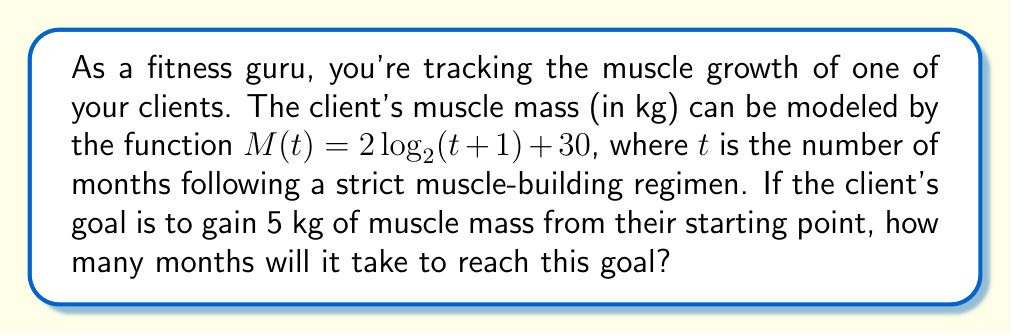Give your solution to this math problem. Let's approach this step-by-step:

1) The initial muscle mass (at $t=0$) is:
   $M(0) = 2\log_2(0+1) + 30 = 2\log_2(1) + 30 = 0 + 30 = 30$ kg

2) The target muscle mass is 5 kg more than the initial:
   Target mass = $30 + 5 = 35$ kg

3) We need to solve the equation:
   $35 = 2\log_2(t+1) + 30$

4) Subtract 30 from both sides:
   $5 = 2\log_2(t+1)$

5) Divide both sides by 2:
   $\frac{5}{2} = \log_2(t+1)$

6) Apply $2^x$ to both sides:
   $2^{\frac{5}{2}} = t+1$

7) Subtract 1 from both sides:
   $2^{\frac{5}{2}} - 1 = t$

8) Calculate the value:
   $2^{\frac{5}{2}} = 2^{2.5} \approx 5.6569$
   $t \approx 5.6569 - 1 = 4.6569$

9) Since we can't have a fractional month, we round up to the nearest whole month.

Therefore, it will take 5 months to reach the goal.
Answer: 5 months 